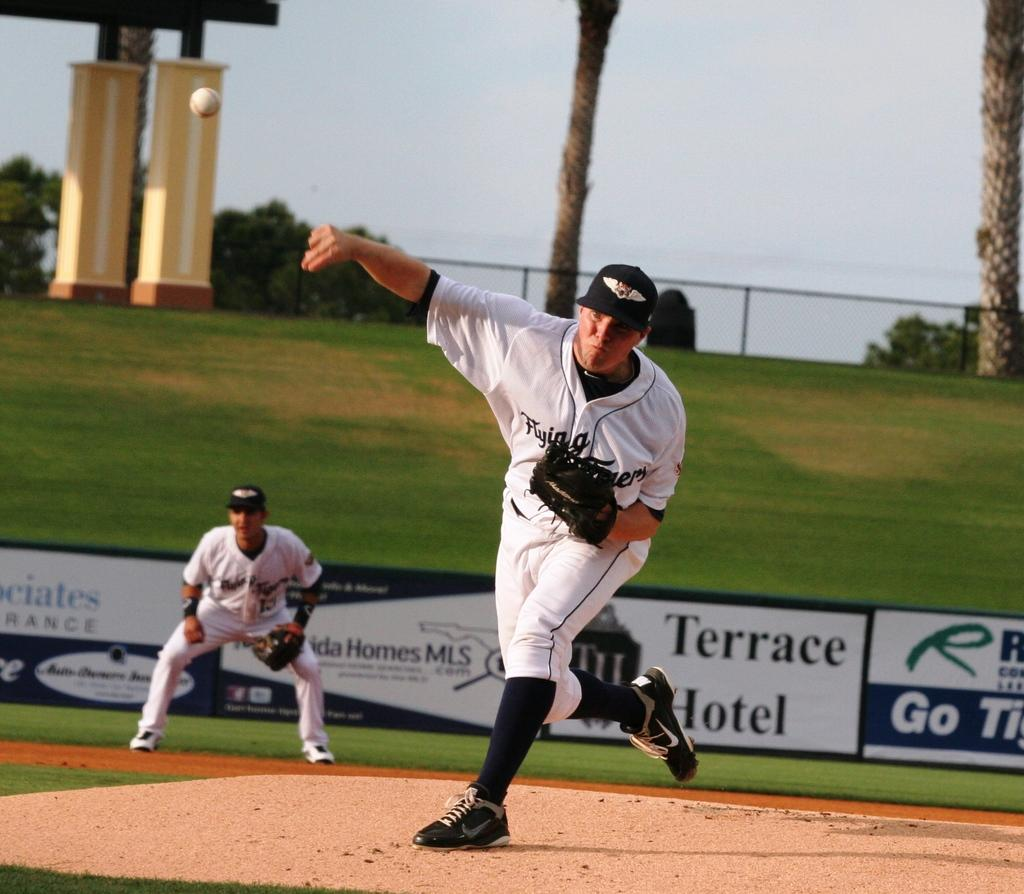<image>
Share a concise interpretation of the image provided. The hotel Terrace is advertised behind the guy who is pitching. 